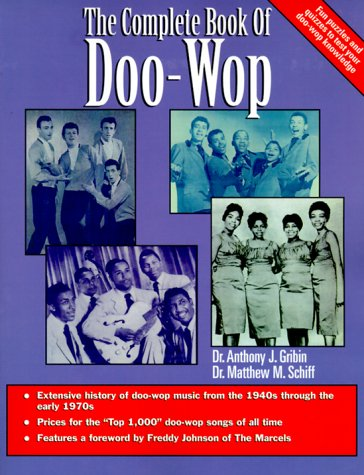What impact did Doo-Wop music have on contemporary genres? Doo-Wop music significantly influenced contemporary music genres by contributing to the development of soul, pop, and rock music, showcasing harmonious vocals and simple beats that became foundational elements in later music. Can you name a few bands or songs that were influenced by Doo-Wop? Bands such as The Beatles and The Beach Boys were influenced by Doo-Wop’s harmonious style, particularly evident in songs like 'Come Together' and 'Surfin' USA'. 